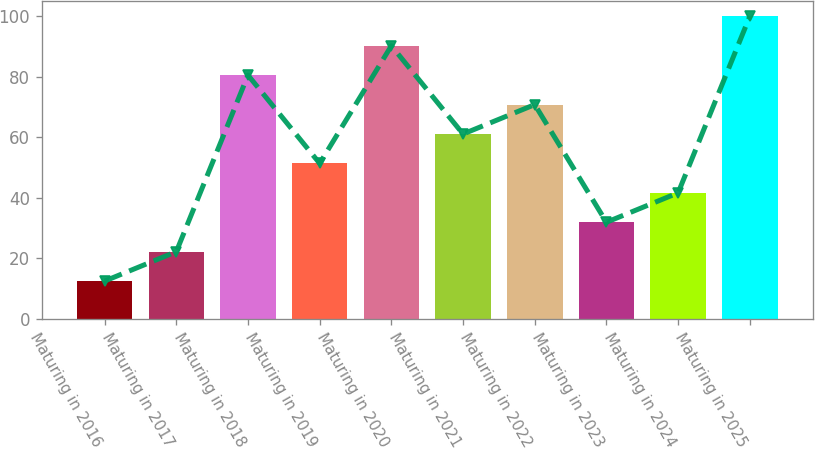<chart> <loc_0><loc_0><loc_500><loc_500><bar_chart><fcel>Maturing in 2016<fcel>Maturing in 2017<fcel>Maturing in 2018<fcel>Maturing in 2019<fcel>Maturing in 2020<fcel>Maturing in 2021<fcel>Maturing in 2022<fcel>Maturing in 2023<fcel>Maturing in 2024<fcel>Maturing in 2025<nl><fcel>12.43<fcel>22.16<fcel>80.54<fcel>51.35<fcel>90.27<fcel>61.08<fcel>70.81<fcel>31.89<fcel>41.62<fcel>100<nl></chart> 